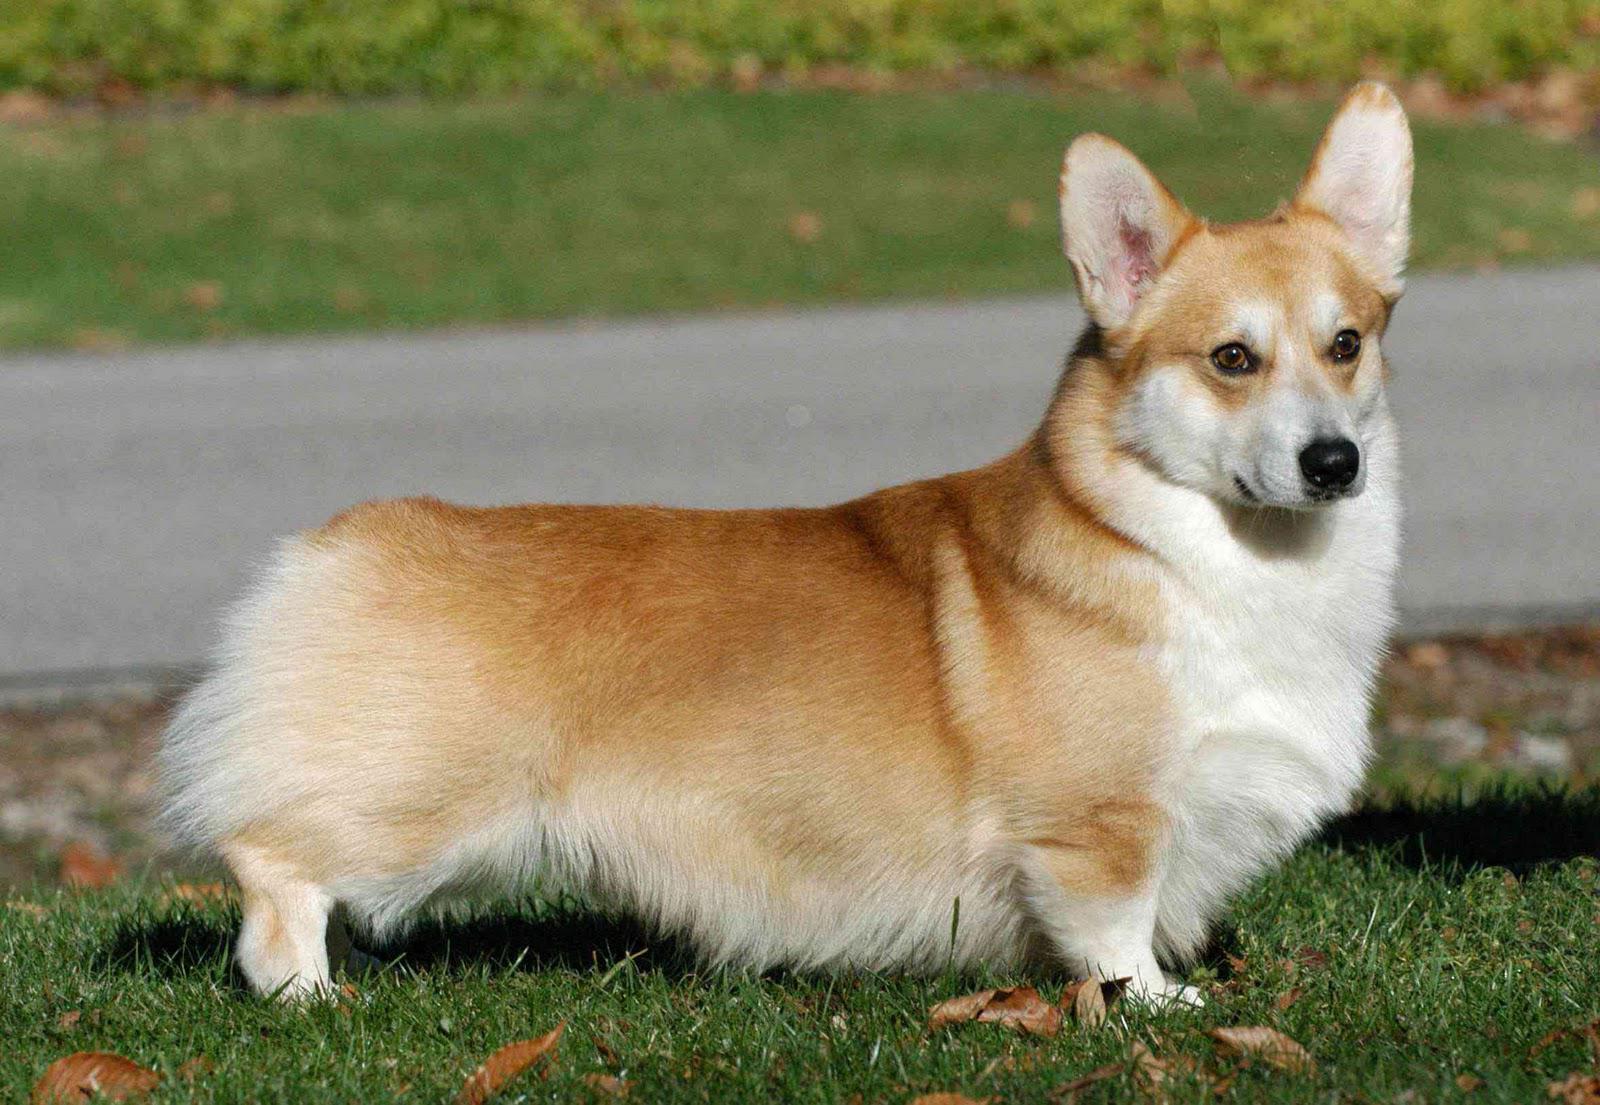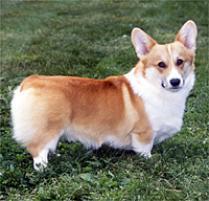The first image is the image on the left, the second image is the image on the right. Given the left and right images, does the statement "Left image shows a corgi dog standing with body turned rightward." hold true? Answer yes or no. Yes. The first image is the image on the left, the second image is the image on the right. Considering the images on both sides, is "The dog in the image on the left is facing right" valid? Answer yes or no. Yes. 